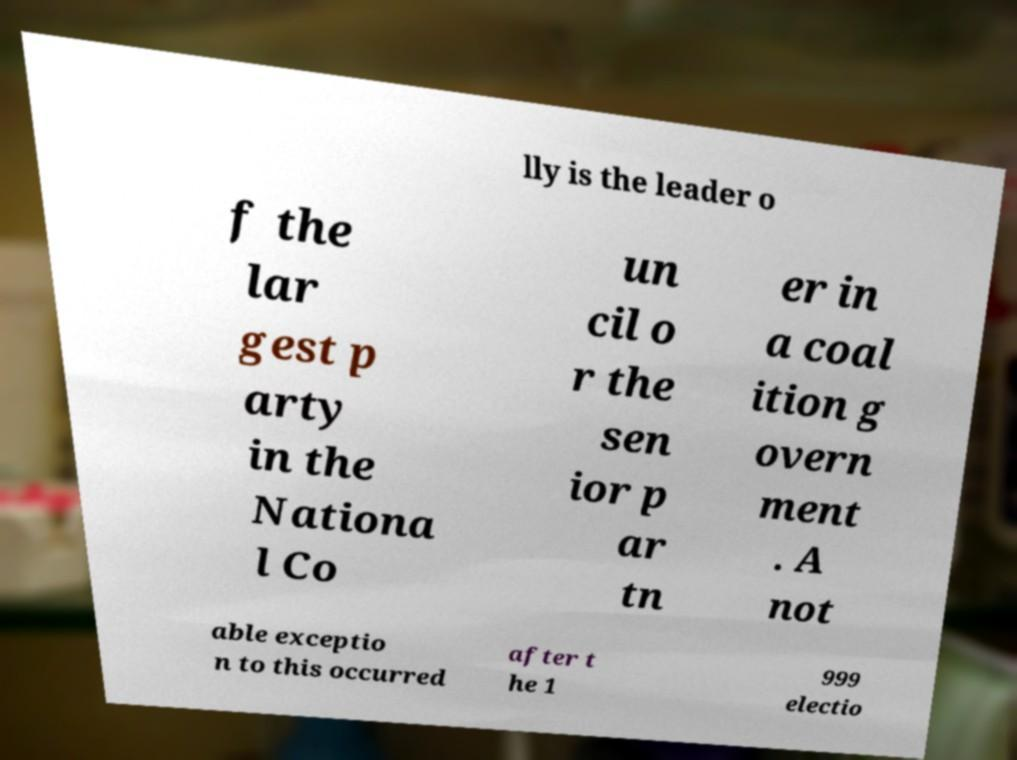Please read and relay the text visible in this image. What does it say? lly is the leader o f the lar gest p arty in the Nationa l Co un cil o r the sen ior p ar tn er in a coal ition g overn ment . A not able exceptio n to this occurred after t he 1 999 electio 